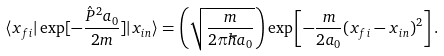<formula> <loc_0><loc_0><loc_500><loc_500>\langle x _ { f i } | \exp [ - \frac { \hat { P } ^ { 2 } a _ { 0 } } { 2 m } ] | x _ { i n } \rangle = \left ( \sqrt { \frac { m } { 2 \pi \hbar { a } _ { 0 } } } \right ) \exp \left [ - \frac { m } { 2 a _ { 0 } } ( x _ { f i } - x _ { i n } ) ^ { 2 } \right ] .</formula> 